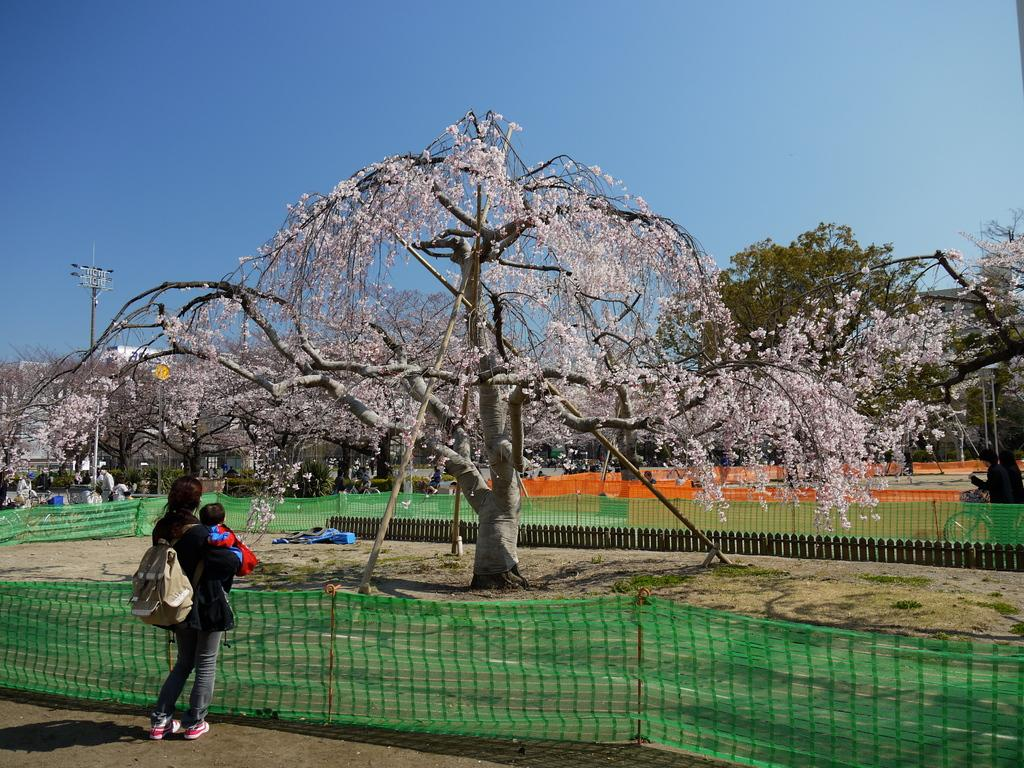What type of vegetation can be seen in the image? There is grass in the image. What structure is present in the image? There is a fence in the image. What other natural elements are visible in the image? There are trees and flowers in the image. What utility pole is present in the image? There is a current pole in the image. What part of the sky is visible in the image? The sky is visible in the image. What is the person in the image wearing? The person is wearing a bag in the image. What is the person doing in the image? The person is holding a child in the image. What type of stitch is the person using to hold the child in the image? There is no stitch present in the image; the person is simply holding the child with their arms. What advice does the person's uncle give them in the image? There is no uncle present in the image, so no advice can be given. 